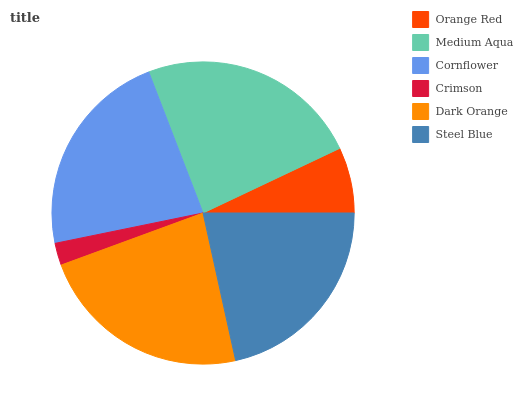Is Crimson the minimum?
Answer yes or no. Yes. Is Medium Aqua the maximum?
Answer yes or no. Yes. Is Cornflower the minimum?
Answer yes or no. No. Is Cornflower the maximum?
Answer yes or no. No. Is Medium Aqua greater than Cornflower?
Answer yes or no. Yes. Is Cornflower less than Medium Aqua?
Answer yes or no. Yes. Is Cornflower greater than Medium Aqua?
Answer yes or no. No. Is Medium Aqua less than Cornflower?
Answer yes or no. No. Is Cornflower the high median?
Answer yes or no. Yes. Is Steel Blue the low median?
Answer yes or no. Yes. Is Medium Aqua the high median?
Answer yes or no. No. Is Dark Orange the low median?
Answer yes or no. No. 